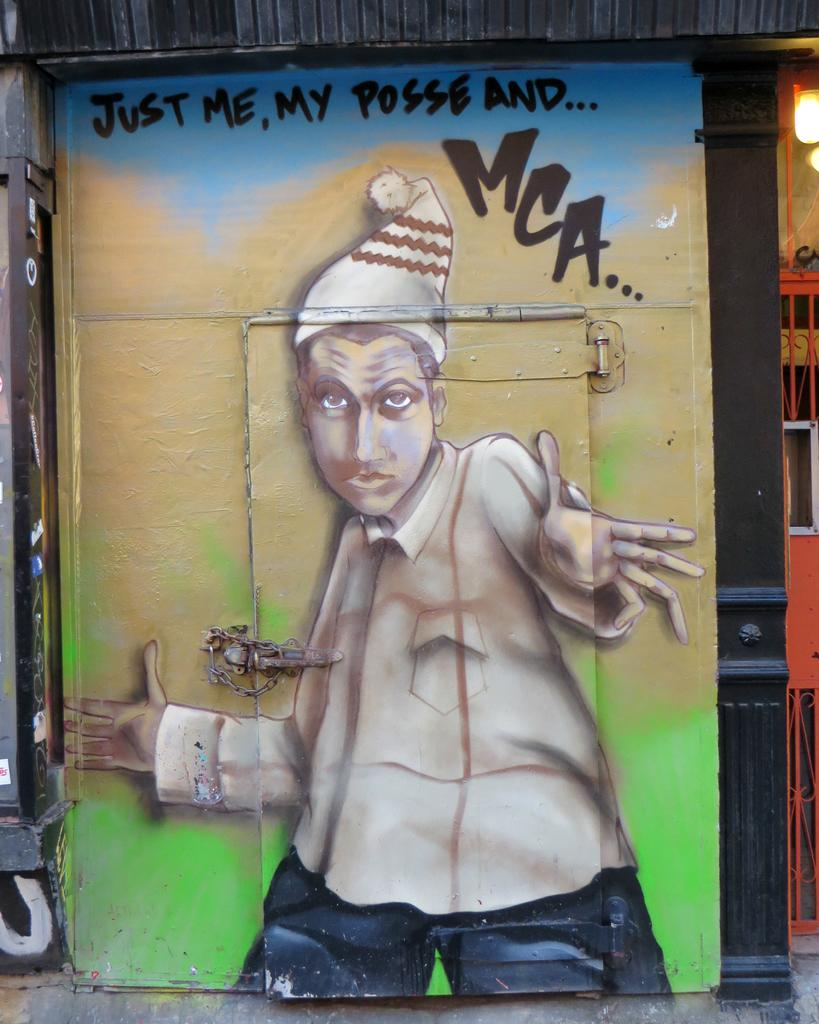What is located in the center of the image? There is a wall in the center of the image. What feature is present in the wall? There is a door in the wall. What decorative element can be seen on the wall? There is a painting on the wall. What can be found on the right side of the image? There is a light and a gate on the right side of the image. What type of animal is depicted in the prose on the wall? There is no prose present on the wall in the image, and therefore no animal can be depicted in it. 